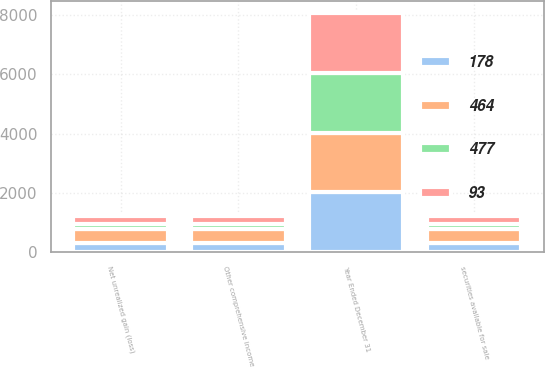<chart> <loc_0><loc_0><loc_500><loc_500><stacked_bar_chart><ecel><fcel>Year Ended December 31<fcel>Net unrealized gain (loss)<fcel>securities available for sale<fcel>Other comprehensive income<nl><fcel>464<fcel>2015<fcel>477<fcel>477<fcel>477<nl><fcel>477<fcel>2015<fcel>178<fcel>178<fcel>178<nl><fcel>178<fcel>2015<fcel>299<fcel>299<fcel>299<nl><fcel>93<fcel>2014<fcel>255<fcel>249<fcel>249<nl></chart> 